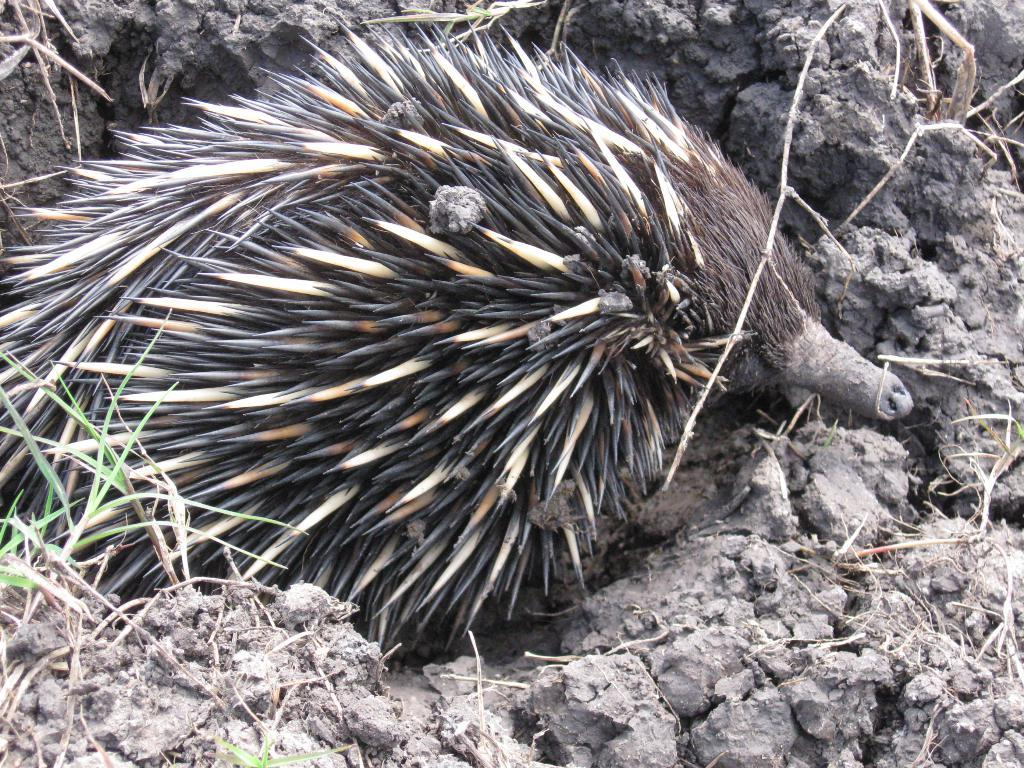What type of creature is present in the image? There is an animal in the image. Where is the animal located in the image? The animal is in the center of the image. What type of appliance is the animal using in the image? There is no appliance present in the image, and therefore no such interaction can be observed. 